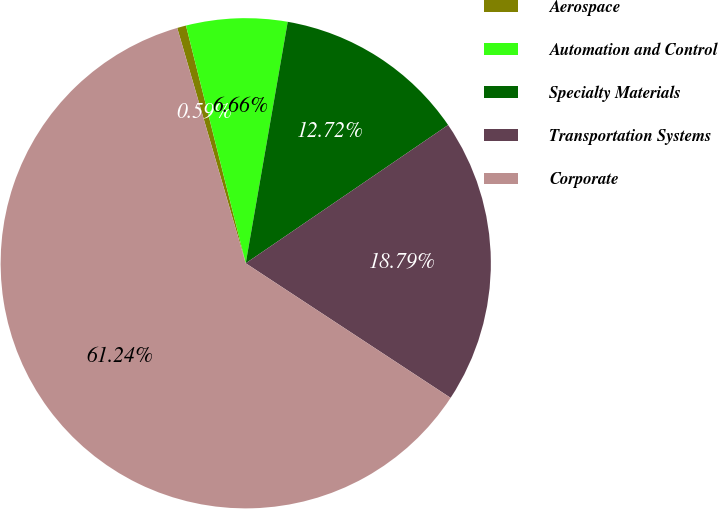Convert chart. <chart><loc_0><loc_0><loc_500><loc_500><pie_chart><fcel>Aerospace<fcel>Automation and Control<fcel>Specialty Materials<fcel>Transportation Systems<fcel>Corporate<nl><fcel>0.59%<fcel>6.66%<fcel>12.72%<fcel>18.79%<fcel>61.24%<nl></chart> 